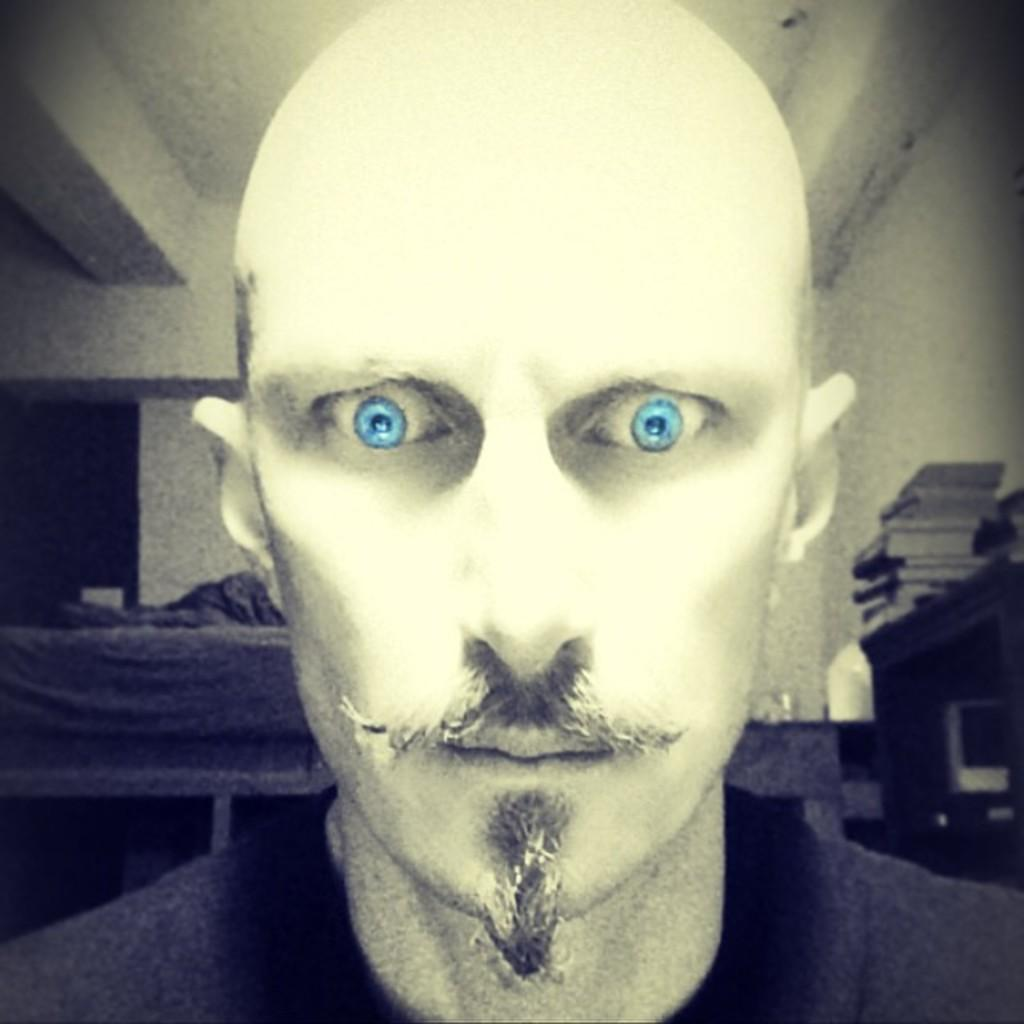What is the main subject of the image? There is a man standing in the image. What is the color scheme of the image? The image is black and white. Can you describe the man's appearance? The man has blue eyes and a bald head. What can be seen in the background of the image? There are books on a table in the background of the image. What type of drink is the man holding in the image? There is no drink visible in the image. The man is not holding anything, and there is no mention of a drink in the provided facts. 